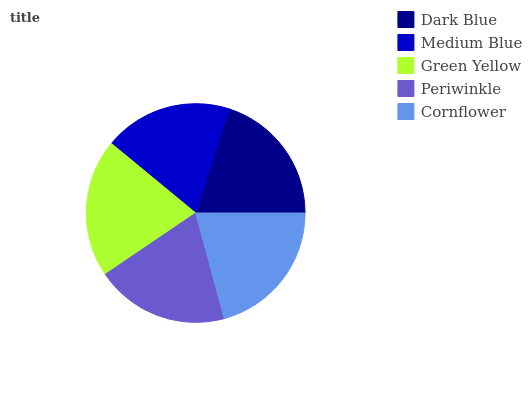Is Medium Blue the minimum?
Answer yes or no. Yes. Is Cornflower the maximum?
Answer yes or no. Yes. Is Green Yellow the minimum?
Answer yes or no. No. Is Green Yellow the maximum?
Answer yes or no. No. Is Green Yellow greater than Medium Blue?
Answer yes or no. Yes. Is Medium Blue less than Green Yellow?
Answer yes or no. Yes. Is Medium Blue greater than Green Yellow?
Answer yes or no. No. Is Green Yellow less than Medium Blue?
Answer yes or no. No. Is Dark Blue the high median?
Answer yes or no. Yes. Is Dark Blue the low median?
Answer yes or no. Yes. Is Periwinkle the high median?
Answer yes or no. No. Is Green Yellow the low median?
Answer yes or no. No. 